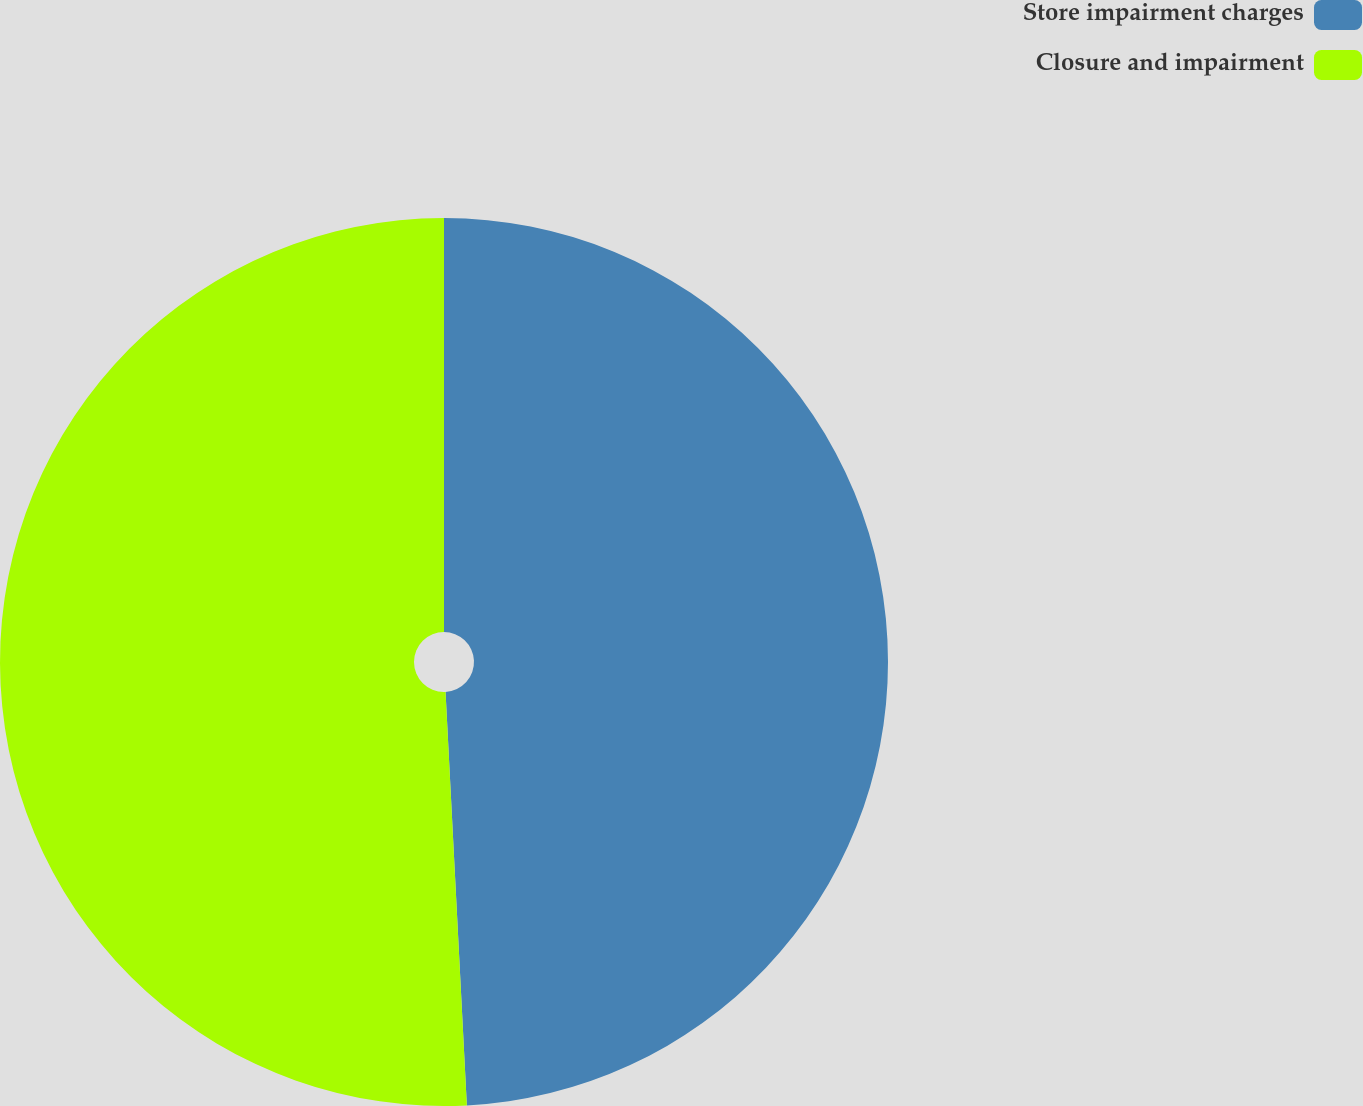Convert chart to OTSL. <chart><loc_0><loc_0><loc_500><loc_500><pie_chart><fcel>Store impairment charges<fcel>Closure and impairment<nl><fcel>49.18%<fcel>50.82%<nl></chart> 